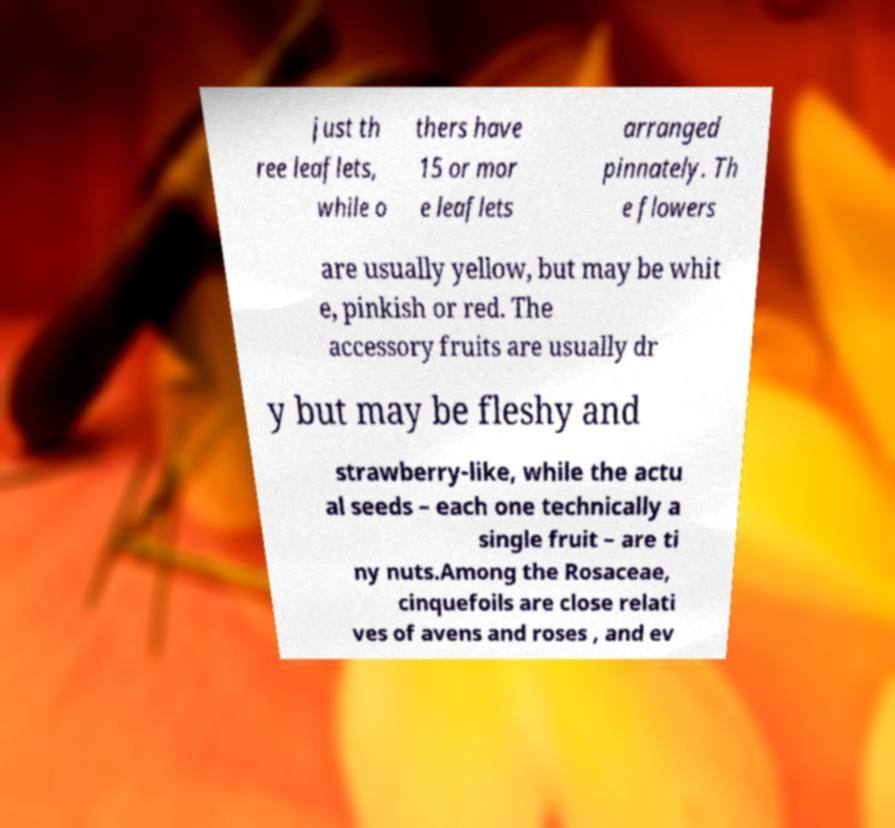Can you accurately transcribe the text from the provided image for me? just th ree leaflets, while o thers have 15 or mor e leaflets arranged pinnately. Th e flowers are usually yellow, but may be whit e, pinkish or red. The accessory fruits are usually dr y but may be fleshy and strawberry-like, while the actu al seeds – each one technically a single fruit – are ti ny nuts.Among the Rosaceae, cinquefoils are close relati ves of avens and roses , and ev 